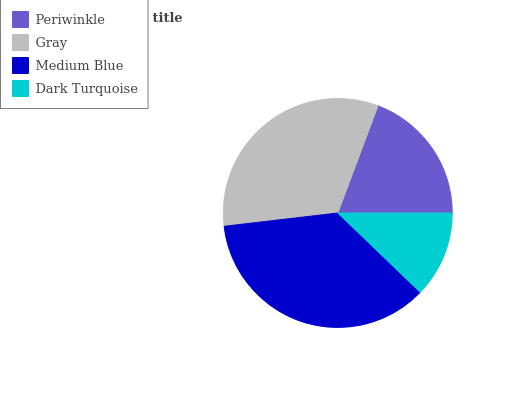Is Dark Turquoise the minimum?
Answer yes or no. Yes. Is Medium Blue the maximum?
Answer yes or no. Yes. Is Gray the minimum?
Answer yes or no. No. Is Gray the maximum?
Answer yes or no. No. Is Gray greater than Periwinkle?
Answer yes or no. Yes. Is Periwinkle less than Gray?
Answer yes or no. Yes. Is Periwinkle greater than Gray?
Answer yes or no. No. Is Gray less than Periwinkle?
Answer yes or no. No. Is Gray the high median?
Answer yes or no. Yes. Is Periwinkle the low median?
Answer yes or no. Yes. Is Dark Turquoise the high median?
Answer yes or no. No. Is Medium Blue the low median?
Answer yes or no. No. 